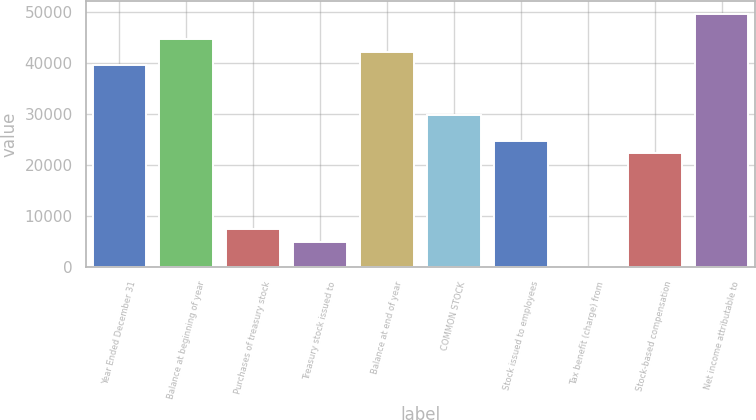<chart> <loc_0><loc_0><loc_500><loc_500><bar_chart><fcel>Year Ended December 31<fcel>Balance at beginning of year<fcel>Purchases of treasury stock<fcel>Treasury stock issued to<fcel>Balance at end of year<fcel>COMMON STOCK<fcel>Stock issued to employees<fcel>Tax benefit (charge) from<fcel>Stock-based compensation<fcel>Net income attributable to<nl><fcel>39674.8<fcel>44633.4<fcel>7443.9<fcel>4964.6<fcel>42154.1<fcel>29757.6<fcel>24799<fcel>6<fcel>22319.7<fcel>49592<nl></chart> 